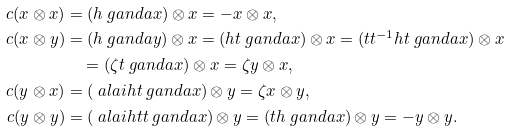<formula> <loc_0><loc_0><loc_500><loc_500>c ( x \otimes x ) & = ( h \ g a n d a x ) \otimes x = - x \otimes x , \\ c ( x \otimes y ) & = ( h \ g a n d a y ) \otimes x = ( h t \ g a n d a x ) \otimes x = ( t t ^ { - 1 } h t \ g a n d a x ) \otimes x \\ & \quad = ( \zeta t \ g a n d a x ) \otimes x = \zeta y \otimes x , \\ c ( y \otimes x ) & = ( \ a l a i h t \ g a n d a x ) \otimes y = \zeta x \otimes y , \\ c ( y \otimes y ) & = ( \ a l a i h t t \ g a n d a x ) \otimes y = ( t h \ g a n d a x ) \otimes y = - y \otimes y .</formula> 